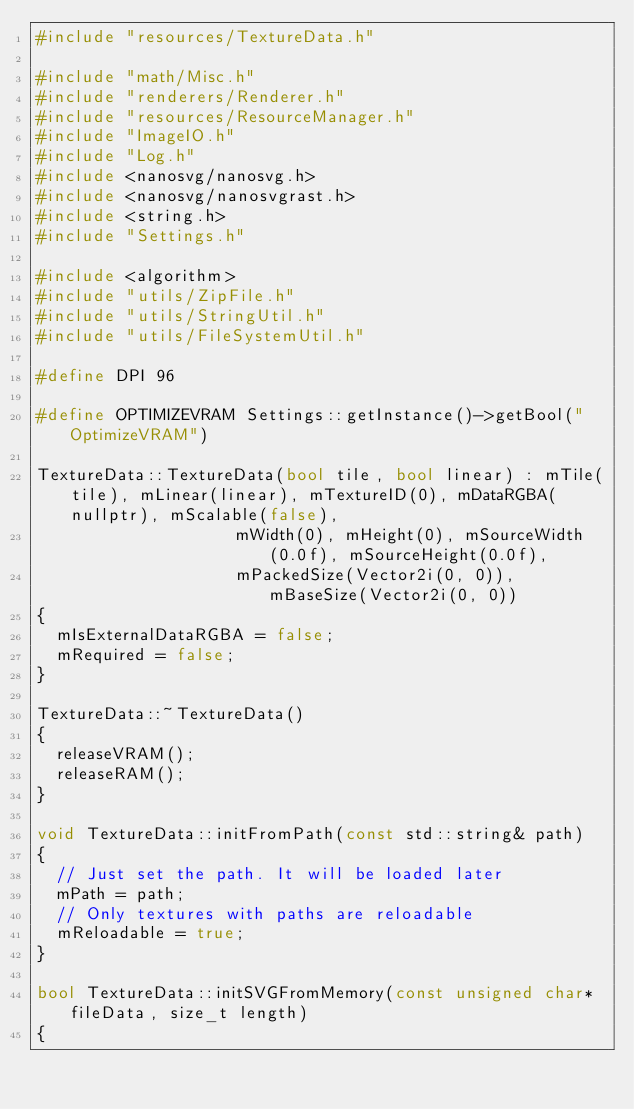<code> <loc_0><loc_0><loc_500><loc_500><_C++_>#include "resources/TextureData.h"

#include "math/Misc.h"
#include "renderers/Renderer.h"
#include "resources/ResourceManager.h"
#include "ImageIO.h"
#include "Log.h"
#include <nanosvg/nanosvg.h>
#include <nanosvg/nanosvgrast.h>
#include <string.h>
#include "Settings.h"

#include <algorithm>
#include "utils/ZipFile.h"
#include "utils/StringUtil.h"
#include "utils/FileSystemUtil.h"

#define DPI 96

#define OPTIMIZEVRAM Settings::getInstance()->getBool("OptimizeVRAM")

TextureData::TextureData(bool tile, bool linear) : mTile(tile), mLinear(linear), mTextureID(0), mDataRGBA(nullptr), mScalable(false),
									  mWidth(0), mHeight(0), mSourceWidth(0.0f), mSourceHeight(0.0f),
									  mPackedSize(Vector2i(0, 0)), mBaseSize(Vector2i(0, 0))
{
	mIsExternalDataRGBA = false;
	mRequired = false;
}

TextureData::~TextureData()
{
	releaseVRAM();
	releaseRAM();
}

void TextureData::initFromPath(const std::string& path)
{
	// Just set the path. It will be loaded later
	mPath = path;
	// Only textures with paths are reloadable
	mReloadable = true;
}

bool TextureData::initSVGFromMemory(const unsigned char* fileData, size_t length)
{</code> 